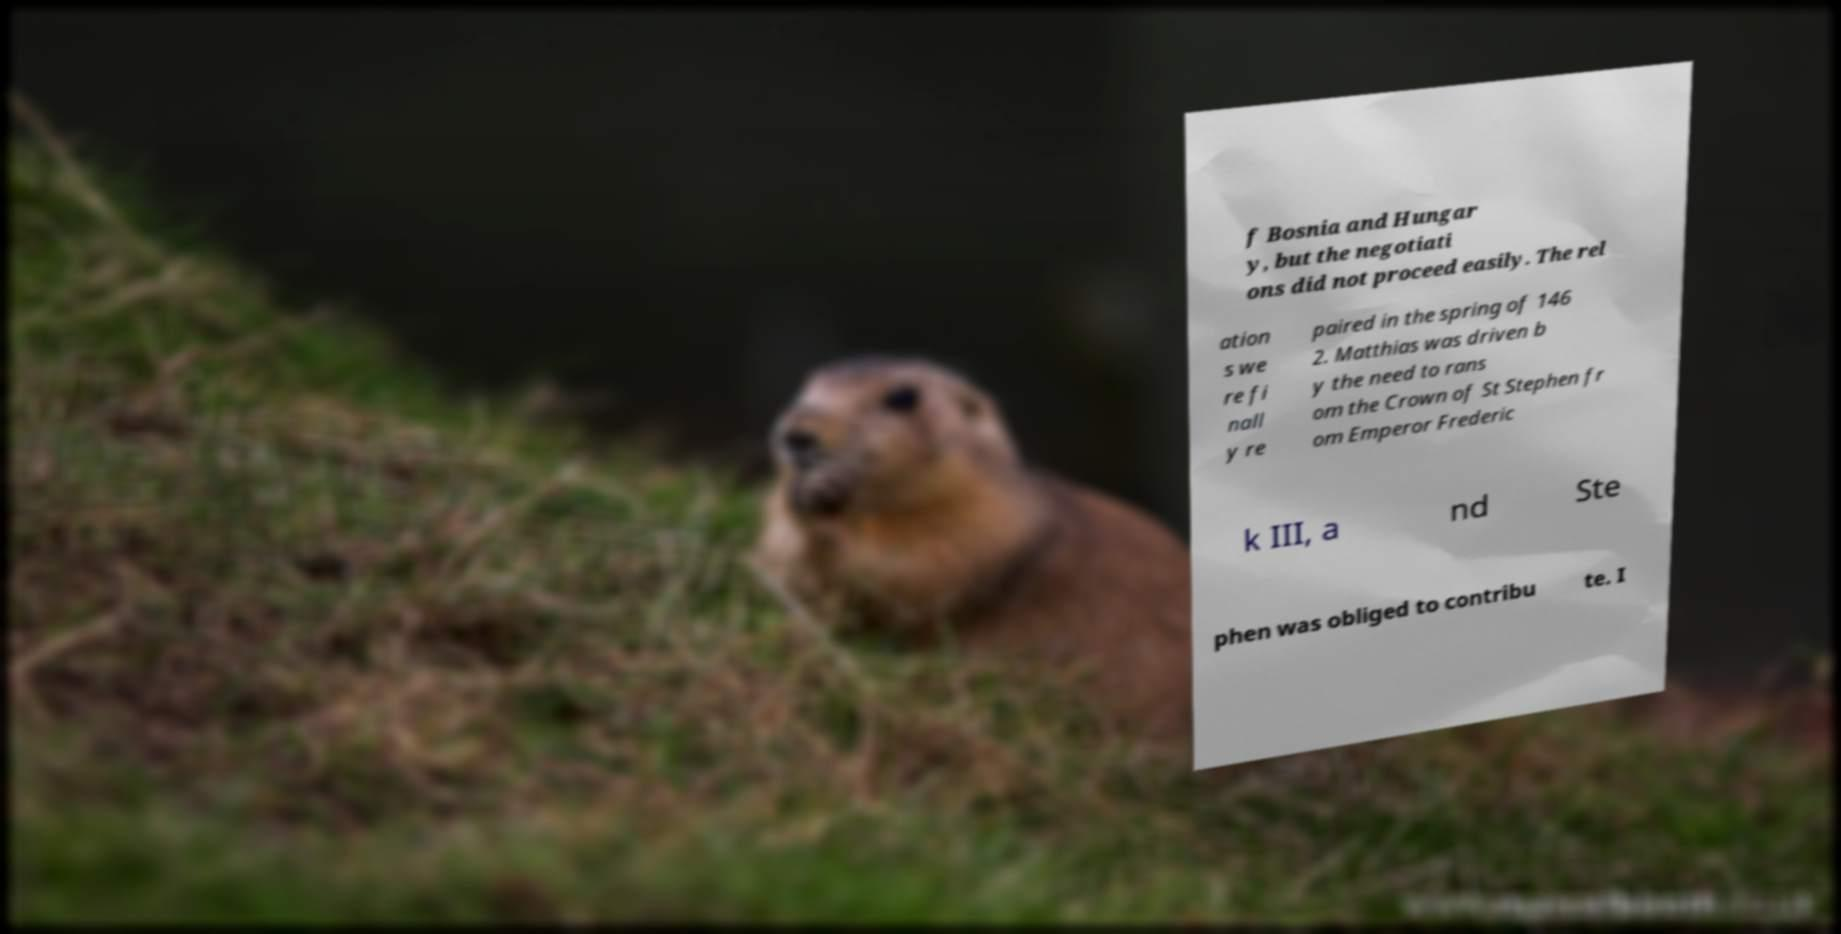Please read and relay the text visible in this image. What does it say? f Bosnia and Hungar y, but the negotiati ons did not proceed easily. The rel ation s we re fi nall y re paired in the spring of 146 2. Matthias was driven b y the need to rans om the Crown of St Stephen fr om Emperor Frederic k III, a nd Ste phen was obliged to contribu te. I 